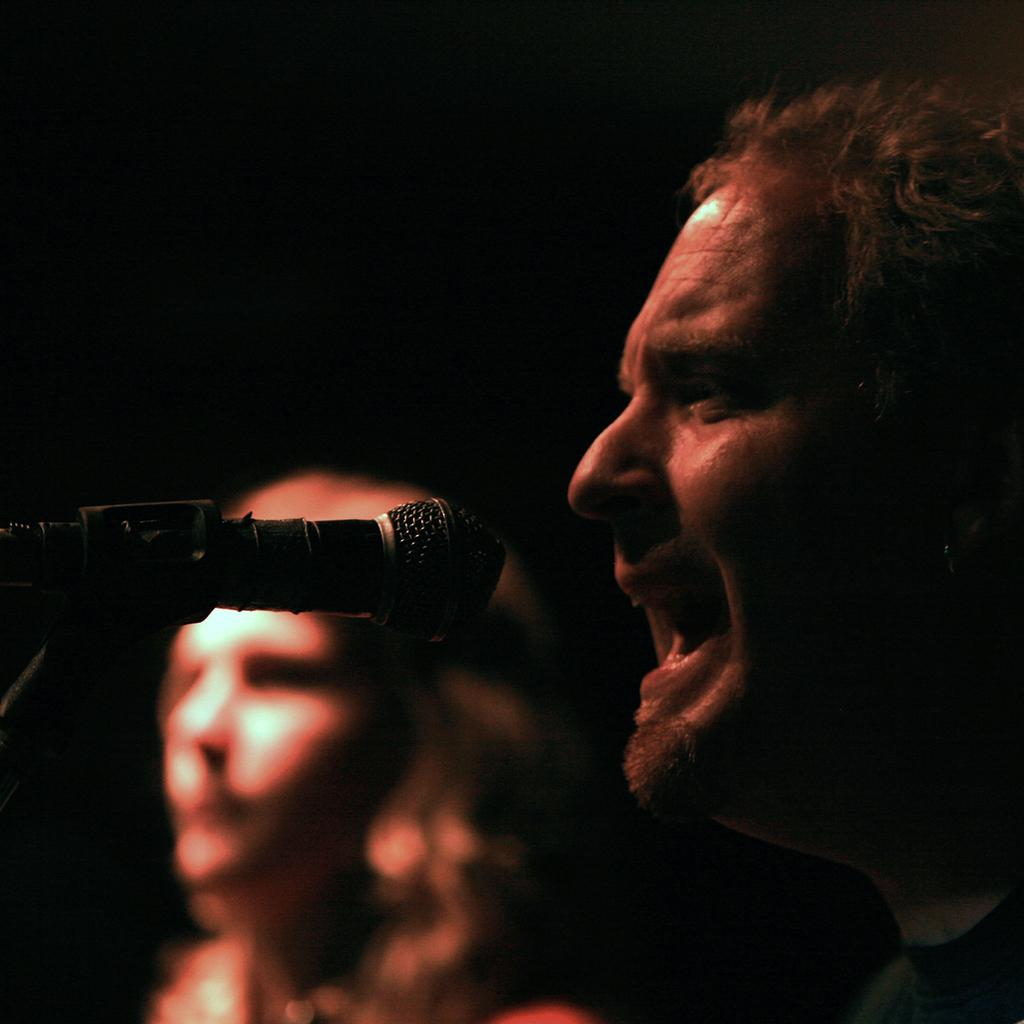How many people are in the image? There are two persons in the image. Where are the two persons located in the image? The two persons are in the center of the image. What object is in front of the two persons? There is a microphone in front of the two persons. What type of science experiment is being conducted with the loaf on the farm in the image? There is no loaf or farm present in the image, and therefore no such experiment can be observed. 